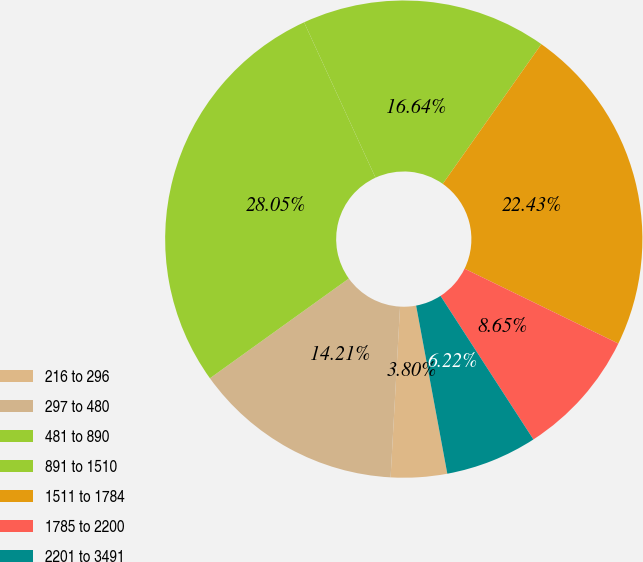Convert chart. <chart><loc_0><loc_0><loc_500><loc_500><pie_chart><fcel>216 to 296<fcel>297 to 480<fcel>481 to 890<fcel>891 to 1510<fcel>1511 to 1784<fcel>1785 to 2200<fcel>2201 to 3491<nl><fcel>3.8%<fcel>14.21%<fcel>28.05%<fcel>16.64%<fcel>22.43%<fcel>8.65%<fcel>6.22%<nl></chart> 